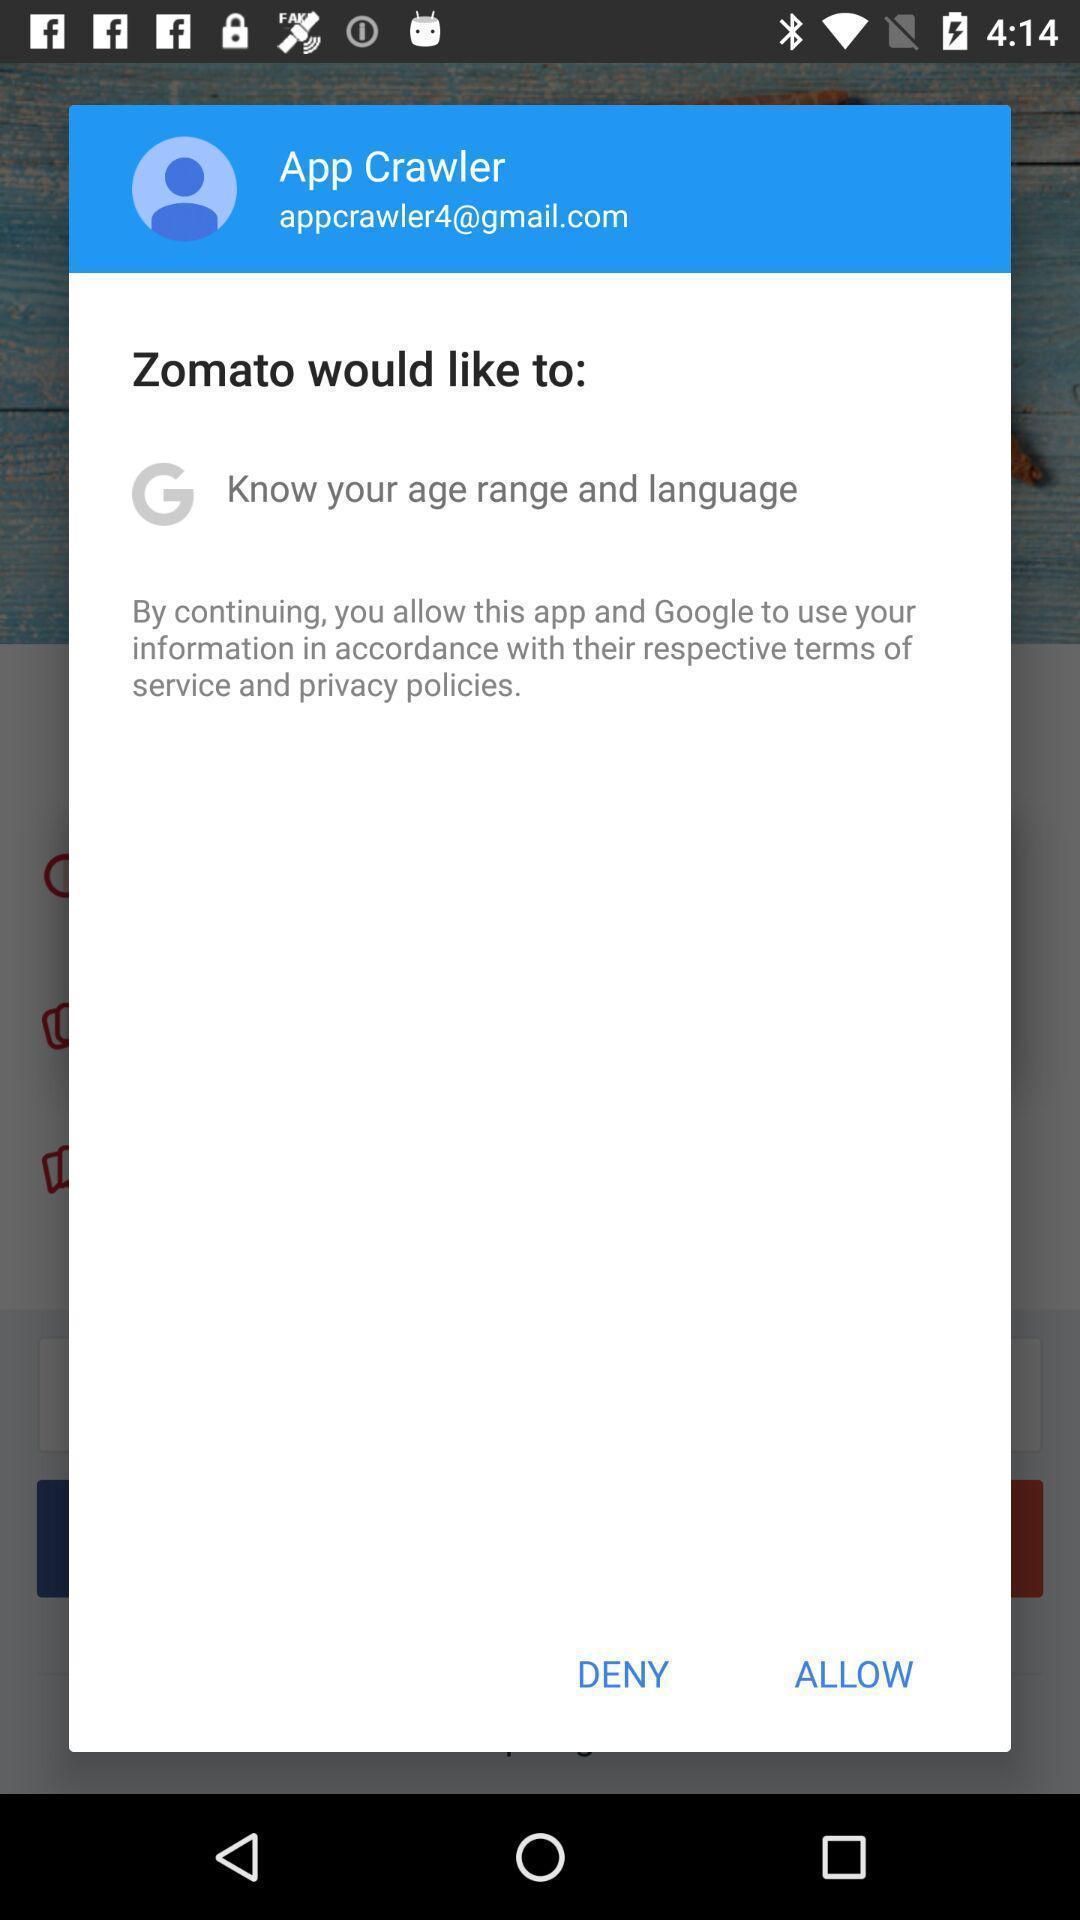Summarize the information in this screenshot. Screen showing information to access its conditions. 